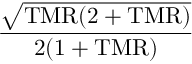Convert formula to latex. <formula><loc_0><loc_0><loc_500><loc_500>\frac { \sqrt { T M R ( 2 + T M R ) } } { 2 ( 1 + T M R ) }</formula> 